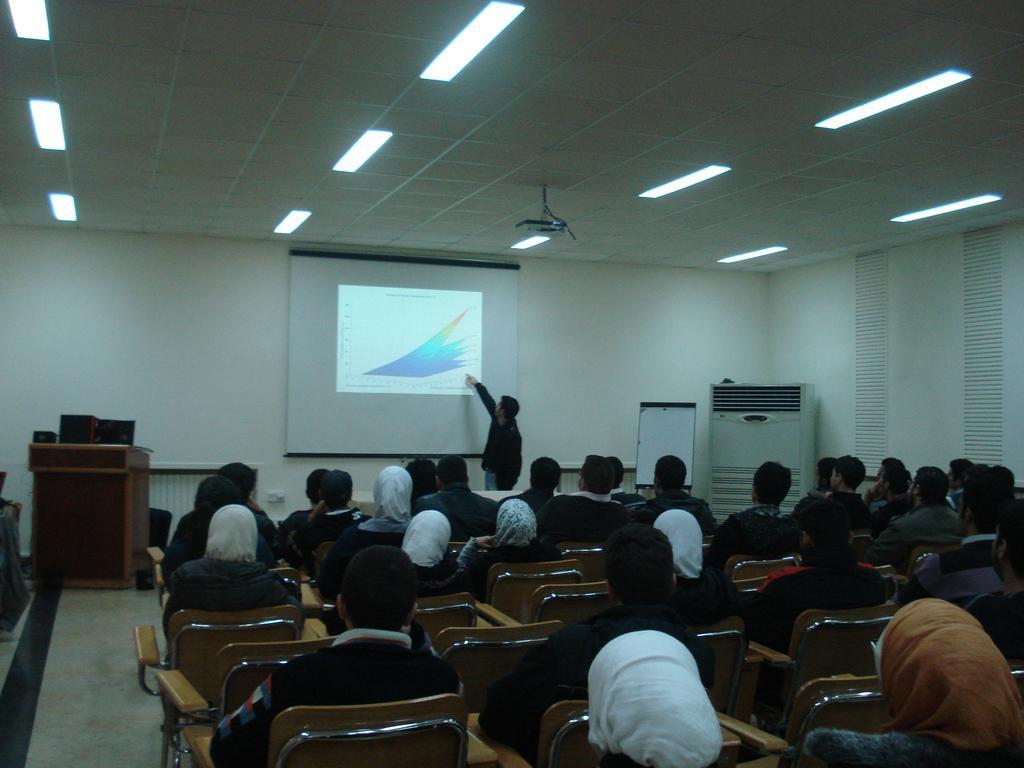How would you summarize this image in a sentence or two? In this picture there are group of people those who are sitting at the right side of the image and there is a projector screen at the center of the image, there is a person who is standing at the center of the image, he is explaining something and there is a desk at the left side of the image. 